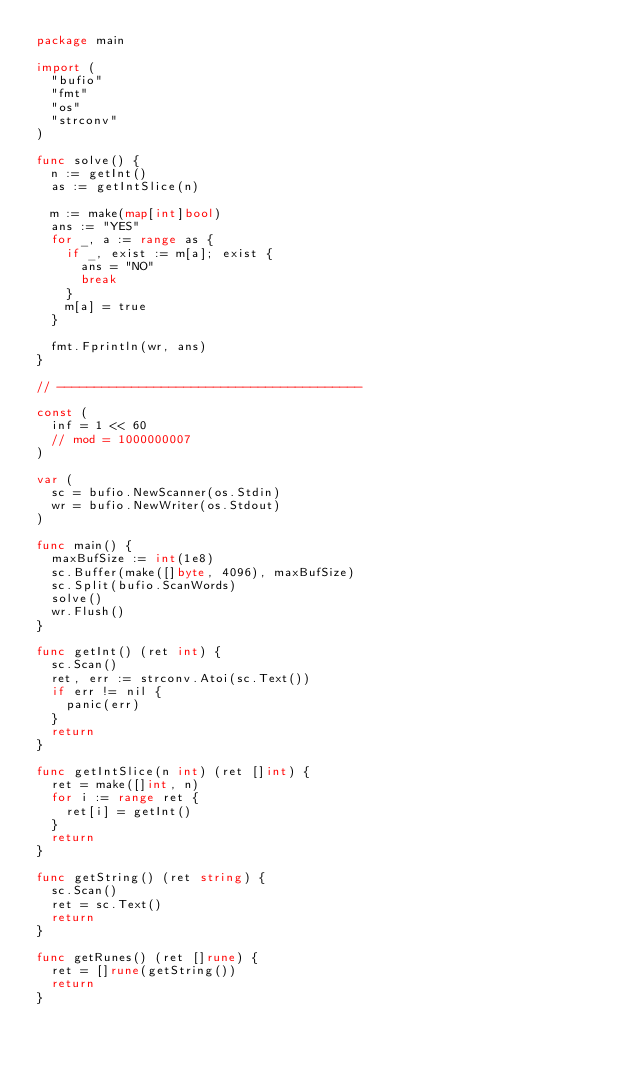<code> <loc_0><loc_0><loc_500><loc_500><_Go_>package main

import (
	"bufio"
	"fmt"
	"os"
	"strconv"
)

func solve() {
	n := getInt()
	as := getIntSlice(n)

	m := make(map[int]bool)
	ans := "YES"
	for _, a := range as {
		if _, exist := m[a]; exist {
			ans = "NO"
			break
		}
		m[a] = true
	}

	fmt.Fprintln(wr, ans)
}

// -----------------------------------------

const (
	inf = 1 << 60
	// mod = 1000000007
)

var (
	sc = bufio.NewScanner(os.Stdin)
	wr = bufio.NewWriter(os.Stdout)
)

func main() {
	maxBufSize := int(1e8)
	sc.Buffer(make([]byte, 4096), maxBufSize)
	sc.Split(bufio.ScanWords)
	solve()
	wr.Flush()
}

func getInt() (ret int) {
	sc.Scan()
	ret, err := strconv.Atoi(sc.Text())
	if err != nil {
		panic(err)
	}
	return
}

func getIntSlice(n int) (ret []int) {
	ret = make([]int, n)
	for i := range ret {
		ret[i] = getInt()
	}
	return
}

func getString() (ret string) {
	sc.Scan()
	ret = sc.Text()
	return
}

func getRunes() (ret []rune) {
	ret = []rune(getString())
	return
}
</code> 